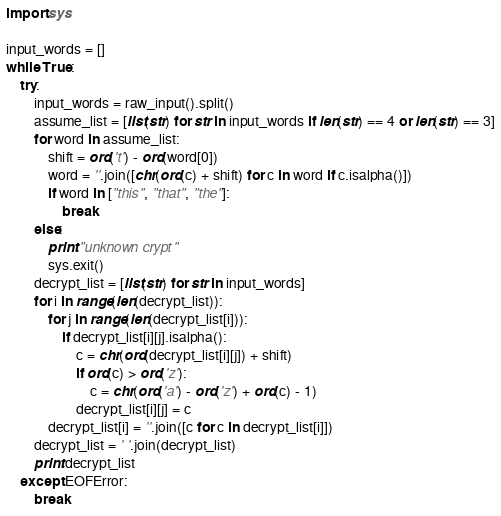Convert code to text. <code><loc_0><loc_0><loc_500><loc_500><_Python_>import sys

input_words = []
while True:
    try:
        input_words = raw_input().split()
        assume_list = [list(str) for str in input_words if len(str) == 4 or len(str) == 3]
        for word in assume_list:
            shift = ord('t') - ord(word[0])
            word = ''.join([chr(ord(c) + shift) for c in word if c.isalpha()])
            if word in ["this", "that", "the"]:
                break
        else:
            print "unknown crypt"
            sys.exit()
        decrypt_list = [list(str) for str in input_words]
        for i in range(len(decrypt_list)):
            for j in range(len(decrypt_list[i])):
                if decrypt_list[i][j].isalpha():
                    c = chr(ord(decrypt_list[i][j]) + shift)
                    if ord(c) > ord('z'):
                        c = chr(ord('a') - ord('z') + ord(c) - 1)
                    decrypt_list[i][j] = c
            decrypt_list[i] = ''.join([c for c in decrypt_list[i]])
        decrypt_list = ' '.join(decrypt_list)
        print decrypt_list
    except EOFError:
        break</code> 